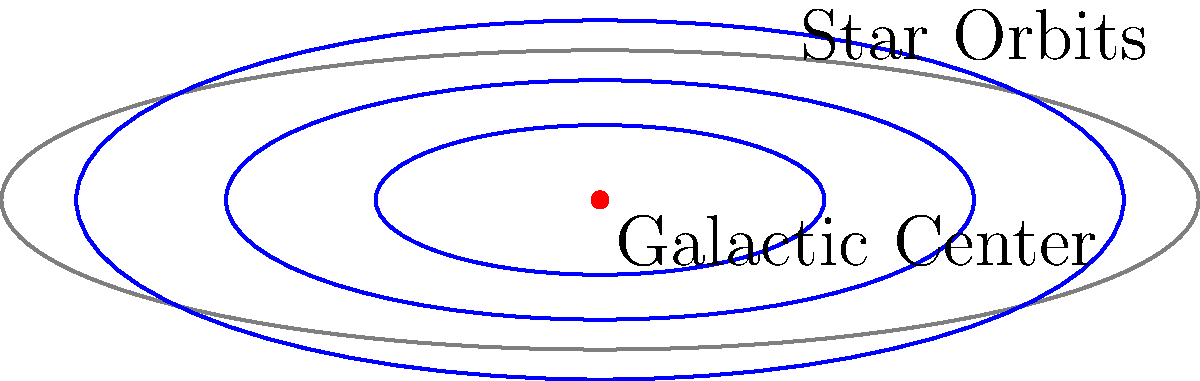Given the observed orbital motions of stars near the galactic center as shown in the diagram, how would you use deep learning techniques to analyze the trajectories and infer the presence of a supermassive black hole? Describe a suitable architecture and explain how it could handle the sequential nature of the stellar motion data. To analyze the trajectories of stars and infer the presence of a supermassive black hole at the galactic center using deep learning techniques, we can follow these steps:

1. Data Preprocessing:
   - Convert the star position data into time series of (x, y, z) coordinates.
   - Normalize the data to account for different scales and units.

2. Architecture Selection:
   - Use a Recurrent Neural Network (RNN) architecture, specifically Long Short-Term Memory (LSTM) or Gated Recurrent Unit (GRU) networks, which are well-suited for sequence modeling.
   - The input to the network would be the time series of star positions.

3. Network Structure:
   - Input layer: Accept the preprocessed time series data.
   - LSTM/GRU layers: Multiple stacked layers to capture temporal dependencies in the star trajectories.
   - Fully connected layers: To process the output of the recurrent layers.
   - Output layer: Predict the presence and mass of the central black hole.

4. Training Process:
   - Use supervised learning with labeled data from simulations or known galactic centers.
   - Apply techniques like teacher forcing to improve training stability.

5. Loss Function:
   - Use a combination of Mean Squared Error (MSE) for trajectory prediction and Binary Cross-Entropy (BCE) for black hole presence classification.

6. Sequence Handling:
   - Employ sequence padding and masking to handle variable-length trajectories.
   - Use attention mechanisms to focus on the most relevant parts of the trajectories.

7. Feature Engineering:
   - Extract additional features like velocity, acceleration, and orbital parameters to enhance the model's predictive power.

8. Model Evaluation:
   - Use metrics such as accuracy, precision, and recall for black hole detection.
   - Employ root mean square error (RMSE) for trajectory prediction accuracy.

9. Interpretation:
   - Apply techniques like SHAP (SHapley Additive exPlanations) values to interpret the model's decisions and understand which trajectory features contribute most to the inference of a black hole's presence.

This approach leverages the power of deep learning to capture complex patterns in the stellar motion data, allowing for accurate inference of the presence and properties of a supermassive black hole at the galactic center.
Answer: LSTM/GRU-based RNN with attention mechanisms for sequence modeling of stellar trajectories 